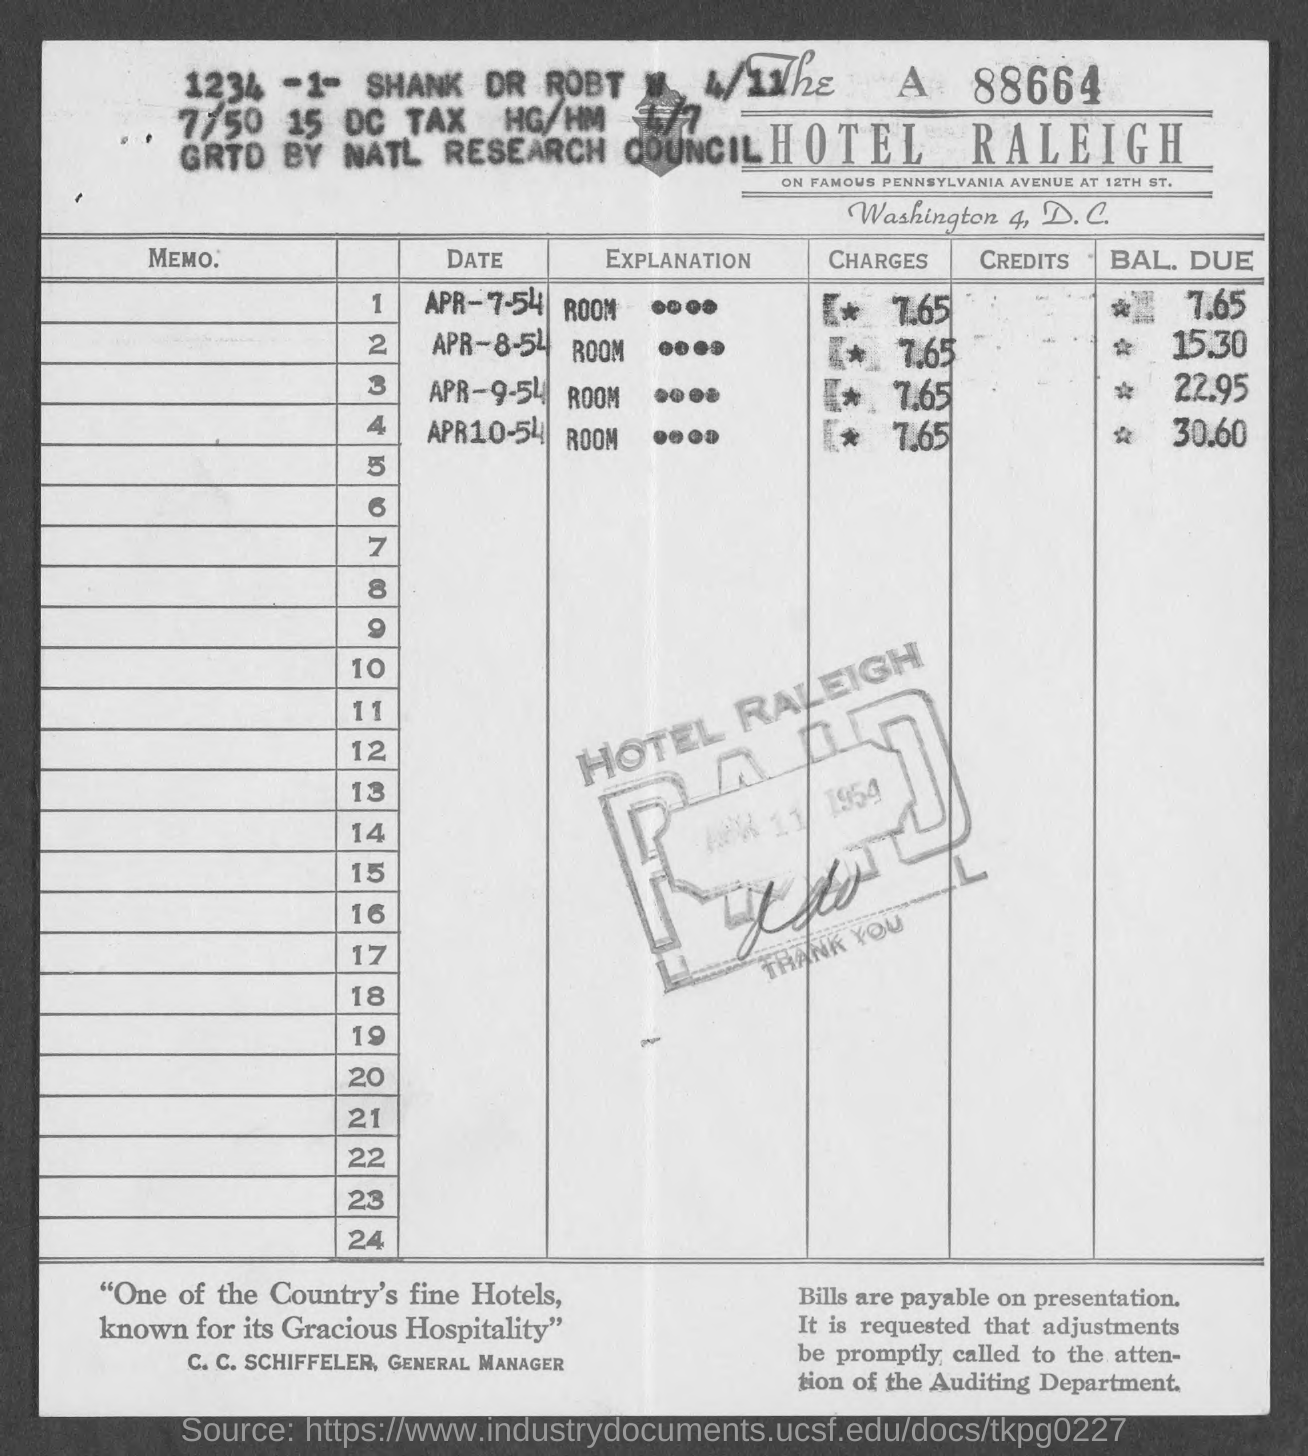Mention a couple of crucial points in this snapshot. The name of the hotel is The HOTEL RALEIGH. C. C. Schiffeler's designation is General Manager. On April 8th, 1954, the reservation for room BAL was made. The due date for the reservation is 15.30. On April 7, 1954, the charges for the room booked were 7.65. The bill number mentioned at the right top corner of the bill is 88664. 